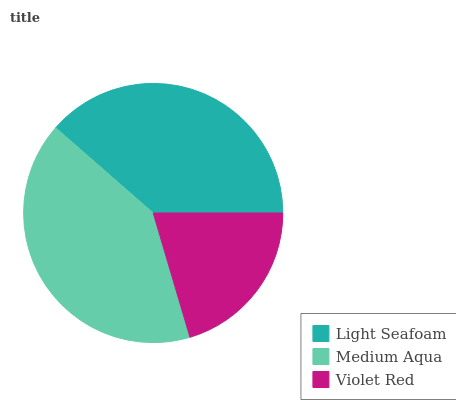Is Violet Red the minimum?
Answer yes or no. Yes. Is Medium Aqua the maximum?
Answer yes or no. Yes. Is Medium Aqua the minimum?
Answer yes or no. No. Is Violet Red the maximum?
Answer yes or no. No. Is Medium Aqua greater than Violet Red?
Answer yes or no. Yes. Is Violet Red less than Medium Aqua?
Answer yes or no. Yes. Is Violet Red greater than Medium Aqua?
Answer yes or no. No. Is Medium Aqua less than Violet Red?
Answer yes or no. No. Is Light Seafoam the high median?
Answer yes or no. Yes. Is Light Seafoam the low median?
Answer yes or no. Yes. Is Medium Aqua the high median?
Answer yes or no. No. Is Medium Aqua the low median?
Answer yes or no. No. 